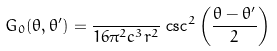<formula> <loc_0><loc_0><loc_500><loc_500>G _ { 0 } ( \theta , \theta ^ { \prime } ) = \frac { } { 1 6 \pi ^ { 2 } c ^ { 3 } r ^ { 2 } } \, \csc ^ { 2 } \left ( \frac { \theta - \theta ^ { \prime } } { 2 } \right )</formula> 